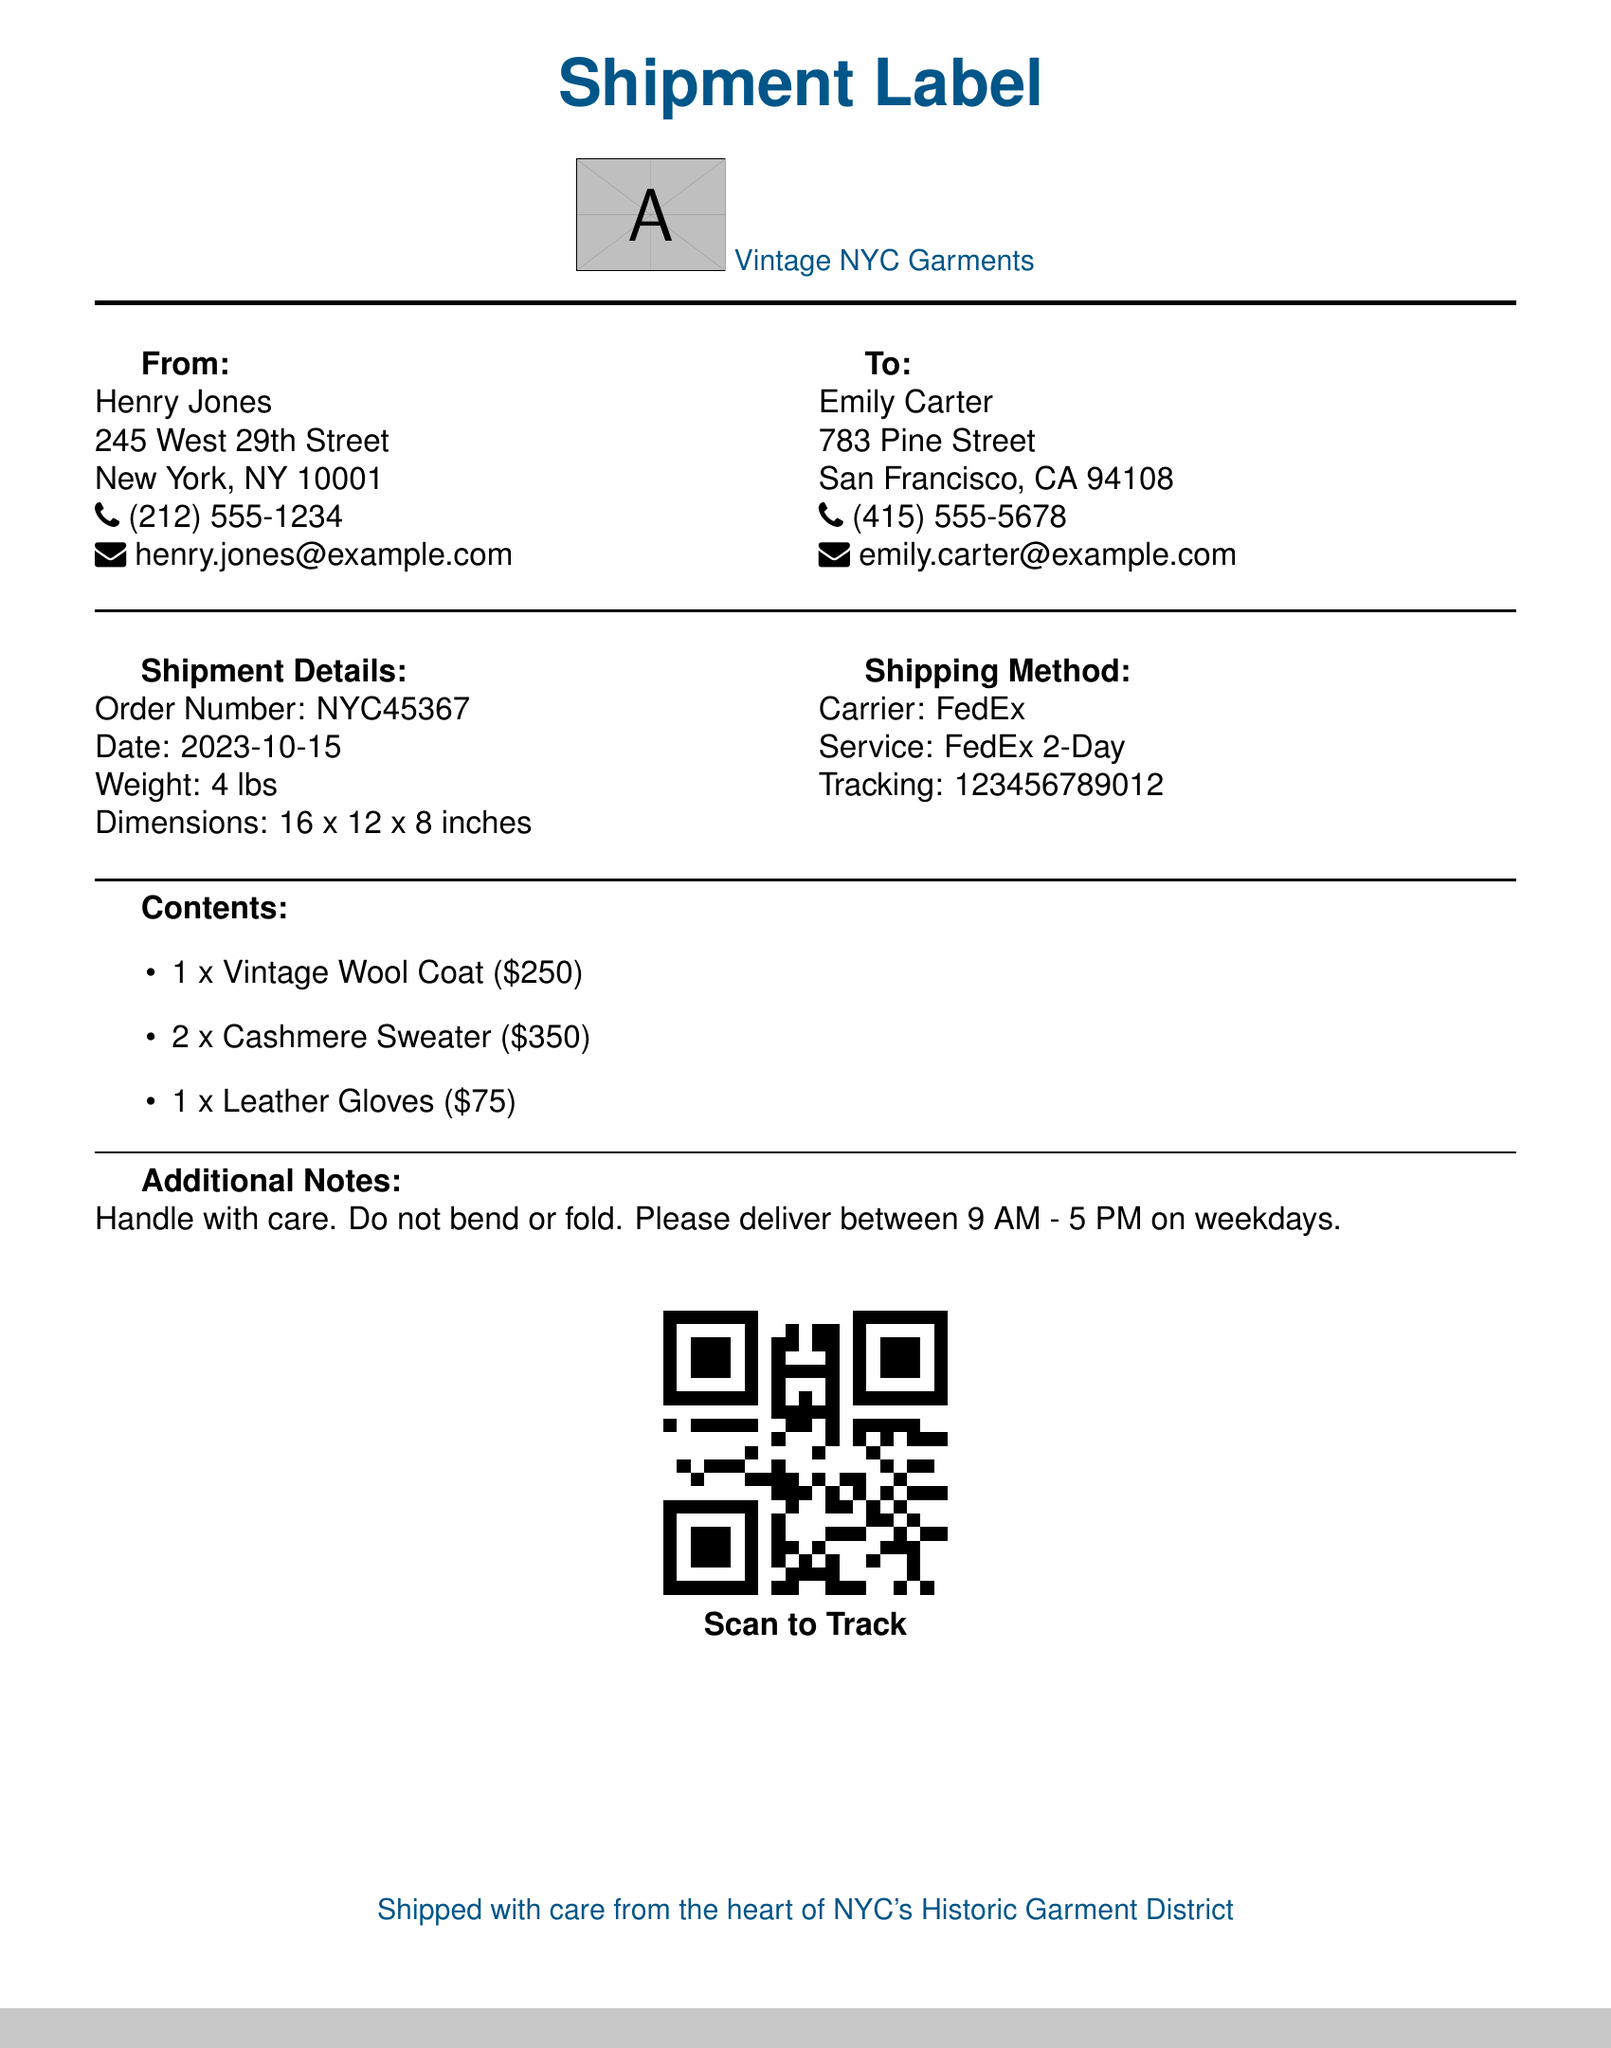What is the order number? The order number is specified in the shipment details section of the document.
Answer: NYC45367 Who is the sender? The sender’s name is provided at the top of the "From" section.
Answer: Henry Jones What are the dimensions of the shipment? The dimensions of the shipment are listed in the shipment details.
Answer: 16 x 12 x 8 inches What is the total weight of the shipment? The total weight is mentioned in the shipment details section.
Answer: 4 lbs What is the shipping method used? The shipping method is outlined in the shipping method section of the document.
Answer: FedEx 2-Day What is the price of the vintage wool coat? The price of each item is listed under "Contents."
Answer: $250 How many cashmere sweaters are included in the shipment? The number of items is specified in the contents list.
Answer: 2 What is the recipient's city? The recipient's address specifies the city in the "To" section.
Answer: San Francisco What note is included regarding the delivery? Additional notes describe handling and delivery instructions.
Answer: Handle with care. Do not bend or fold 